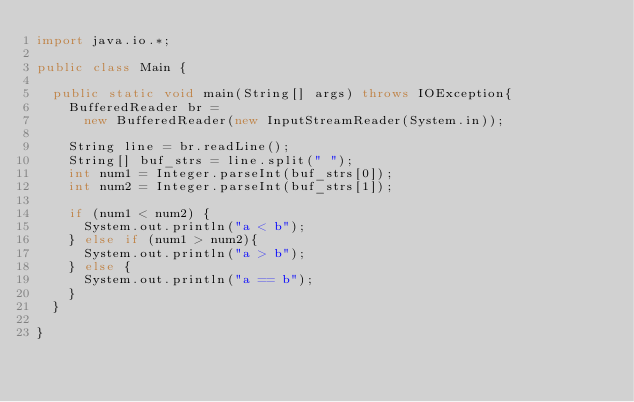<code> <loc_0><loc_0><loc_500><loc_500><_Java_>import java.io.*;

public class Main {

	public static void main(String[] args) throws IOException{
		BufferedReader br =
			new BufferedReader(new InputStreamReader(System.in));
		
		String line = br.readLine();
		String[] buf_strs = line.split(" ");
		int num1 = Integer.parseInt(buf_strs[0]);
		int num2 = Integer.parseInt(buf_strs[1]);
		
		if (num1 < num2) {
			System.out.println("a < b");
		} else if (num1 > num2){
			System.out.println("a > b");
		} else {
			System.out.println("a == b");
		}
	}

}</code> 